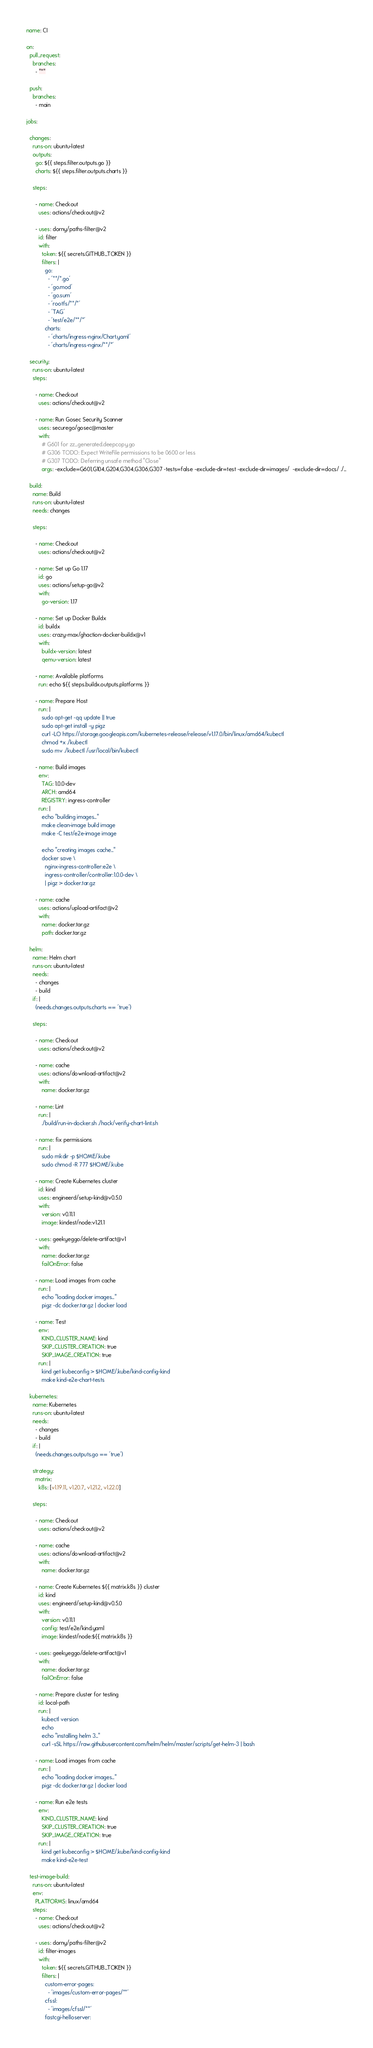<code> <loc_0><loc_0><loc_500><loc_500><_YAML_>name: CI

on:
  pull_request:
    branches:
      - "*"

  push:
    branches:
      - main

jobs:

  changes:
    runs-on: ubuntu-latest
    outputs:
      go: ${{ steps.filter.outputs.go }}
      charts: ${{ steps.filter.outputs.charts }}

    steps:

      - name: Checkout
        uses: actions/checkout@v2

      - uses: dorny/paths-filter@v2
        id: filter
        with:
          token: ${{ secrets.GITHUB_TOKEN }}
          filters: |
            go:
              - '**/*.go'
              - 'go.mod'
              - 'go.sum'
              - 'rootfs/**/*'
              - 'TAG'
              - 'test/e2e/**/*'
            charts:
              - 'charts/ingress-nginx/Chart.yaml'
              - 'charts/ingress-nginx/**/*'

  security:
    runs-on: ubuntu-latest
    steps:

      - name: Checkout
        uses: actions/checkout@v2

      - name: Run Gosec Security Scanner
        uses: securego/gosec@master
        with:
          # G601 for zz_generated.deepcopy.go
          # G306 TODO: Expect WriteFile permissions to be 0600 or less
          # G307 TODO: Deferring unsafe method "Close"
          args: -exclude=G601,G104,G204,G304,G306,G307 -tests=false -exclude-dir=test -exclude-dir=images/  -exclude-dir=docs/ ./...

  build:
    name: Build
    runs-on: ubuntu-latest
    needs: changes

    steps:

      - name: Checkout
        uses: actions/checkout@v2

      - name: Set up Go 1.17
        id: go
        uses: actions/setup-go@v2
        with:
          go-version: 1.17

      - name: Set up Docker Buildx
        id: buildx
        uses: crazy-max/ghaction-docker-buildx@v1
        with:
          buildx-version: latest
          qemu-version: latest

      - name: Available platforms
        run: echo ${{ steps.buildx.outputs.platforms }}

      - name: Prepare Host
        run: |
          sudo apt-get -qq update || true
          sudo apt-get install -y pigz
          curl -LO https://storage.googleapis.com/kubernetes-release/release/v1.17.0/bin/linux/amd64/kubectl
          chmod +x ./kubectl
          sudo mv ./kubectl /usr/local/bin/kubectl

      - name: Build images
        env:
          TAG: 1.0.0-dev
          ARCH: amd64
          REGISTRY: ingress-controller
        run: |
          echo "building images..."
          make clean-image build image
          make -C test/e2e-image image

          echo "creating images cache..."
          docker save \
            nginx-ingress-controller:e2e \
            ingress-controller/controller:1.0.0-dev \
            | pigz > docker.tar.gz

      - name: cache
        uses: actions/upload-artifact@v2
        with:
          name: docker.tar.gz
          path: docker.tar.gz

  helm:
    name: Helm chart
    runs-on: ubuntu-latest
    needs:
      - changes
      - build
    if: |
      (needs.changes.outputs.charts == 'true')

    steps:

      - name: Checkout
        uses: actions/checkout@v2

      - name: cache
        uses: actions/download-artifact@v2
        with:
          name: docker.tar.gz

      - name: Lint
        run: |
          ./build/run-in-docker.sh ./hack/verify-chart-lint.sh

      - name: fix permissions
        run: |
          sudo mkdir -p $HOME/.kube
          sudo chmod -R 777 $HOME/.kube

      - name: Create Kubernetes cluster
        id: kind
        uses: engineerd/setup-kind@v0.5.0
        with:
          version: v0.11.1
          image: kindest/node:v1.21.1

      - uses: geekyeggo/delete-artifact@v1
        with:
          name: docker.tar.gz
          failOnError: false

      - name: Load images from cache
        run: |
          echo "loading docker images..."
          pigz -dc docker.tar.gz | docker load

      - name: Test
        env:
          KIND_CLUSTER_NAME: kind
          SKIP_CLUSTER_CREATION: true
          SKIP_IMAGE_CREATION: true
        run: |
          kind get kubeconfig > $HOME/.kube/kind-config-kind
          make kind-e2e-chart-tests

  kubernetes:
    name: Kubernetes
    runs-on: ubuntu-latest
    needs:
      - changes
      - build
    if: |
      (needs.changes.outputs.go == 'true')

    strategy:
      matrix:
        k8s: [v1.19.11, v1.20.7, v1.21.2, v1.22.0]

    steps:

      - name: Checkout
        uses: actions/checkout@v2

      - name: cache
        uses: actions/download-artifact@v2
        with:
          name: docker.tar.gz

      - name: Create Kubernetes ${{ matrix.k8s }} cluster
        id: kind
        uses: engineerd/setup-kind@v0.5.0
        with:
          version: v0.11.1
          config: test/e2e/kind.yaml
          image: kindest/node:${{ matrix.k8s }}

      - uses: geekyeggo/delete-artifact@v1
        with:
          name: docker.tar.gz
          failOnError: false

      - name: Prepare cluster for testing
        id: local-path
        run: |
          kubectl version
          echo
          echo "installing helm 3..."
          curl -sSL https://raw.githubusercontent.com/helm/helm/master/scripts/get-helm-3 | bash

      - name: Load images from cache
        run: |
          echo "loading docker images..."
          pigz -dc docker.tar.gz | docker load

      - name: Run e2e tests
        env:
          KIND_CLUSTER_NAME: kind
          SKIP_CLUSTER_CREATION: true
          SKIP_IMAGE_CREATION: true
        run: |
          kind get kubeconfig > $HOME/.kube/kind-config-kind
          make kind-e2e-test

  test-image-build:
    runs-on: ubuntu-latest
    env:
      PLATFORMS: linux/amd64
    steps:
      - name: Checkout
        uses: actions/checkout@v2

      - uses: dorny/paths-filter@v2
        id: filter-images
        with:
          token: ${{ secrets.GITHUB_TOKEN }}
          filters: |
            custom-error-pages:
              - 'images/custom-error-pages/**'
            cfssl:
              - 'images/cfssl/**'
            fastcgi-helloserver:</code> 